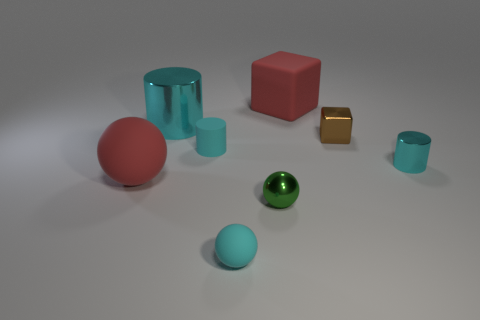What is the material of the big cylinder that is the same color as the small metal cylinder?
Your answer should be compact. Metal. Do the matte object that is in front of the red sphere and the metallic cylinder in front of the large cyan cylinder have the same color?
Offer a terse response. Yes. The small metal object that is the same color as the big shiny cylinder is what shape?
Provide a short and direct response. Cylinder. There is a rubber sphere left of the cyan sphere; is it the same size as the cyan shiny cylinder left of the brown object?
Provide a succinct answer. Yes. How many things are either gray metal objects or things that are left of the small cyan ball?
Your response must be concise. 3. What size is the cylinder right of the rubber cylinder?
Your answer should be compact. Small. Are there fewer brown objects that are in front of the green thing than big objects that are behind the big cyan metal cylinder?
Your answer should be very brief. Yes. What material is the object that is to the right of the big cylinder and behind the brown shiny thing?
Ensure brevity in your answer.  Rubber. The red rubber thing on the left side of the small cyan rubber thing that is in front of the tiny shiny cylinder is what shape?
Offer a very short reply. Sphere. Is the small shiny sphere the same color as the big metal cylinder?
Keep it short and to the point. No. 